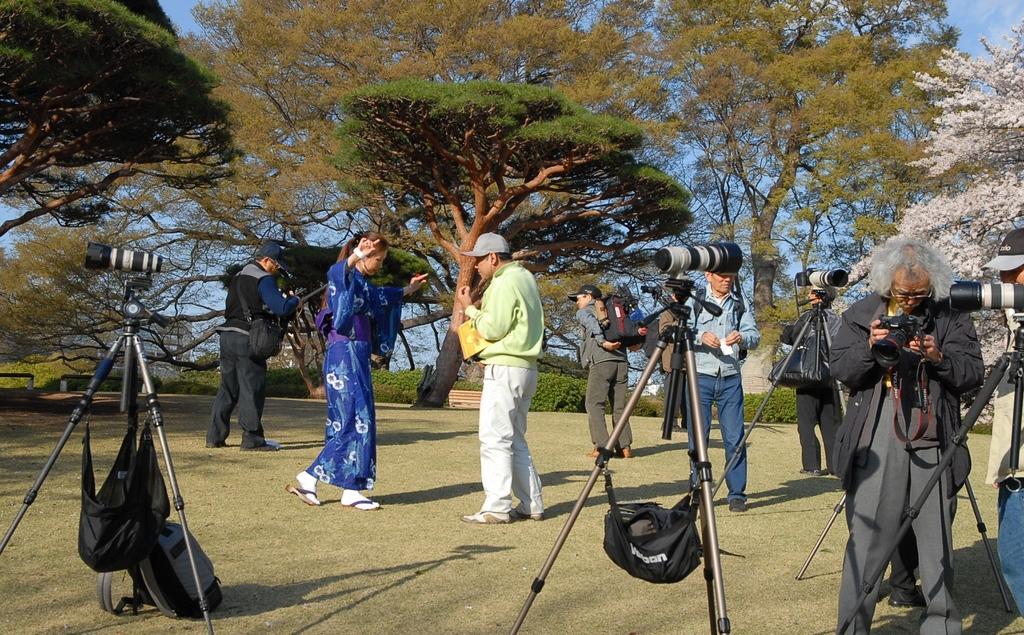How would you summarize this image in a sentence or two? In this image, we can see people and stands with camera. At the bottom, we can see a backpack on the ground. Here we can see few people are holding some objects. Background we can see trees, benches and sky. 